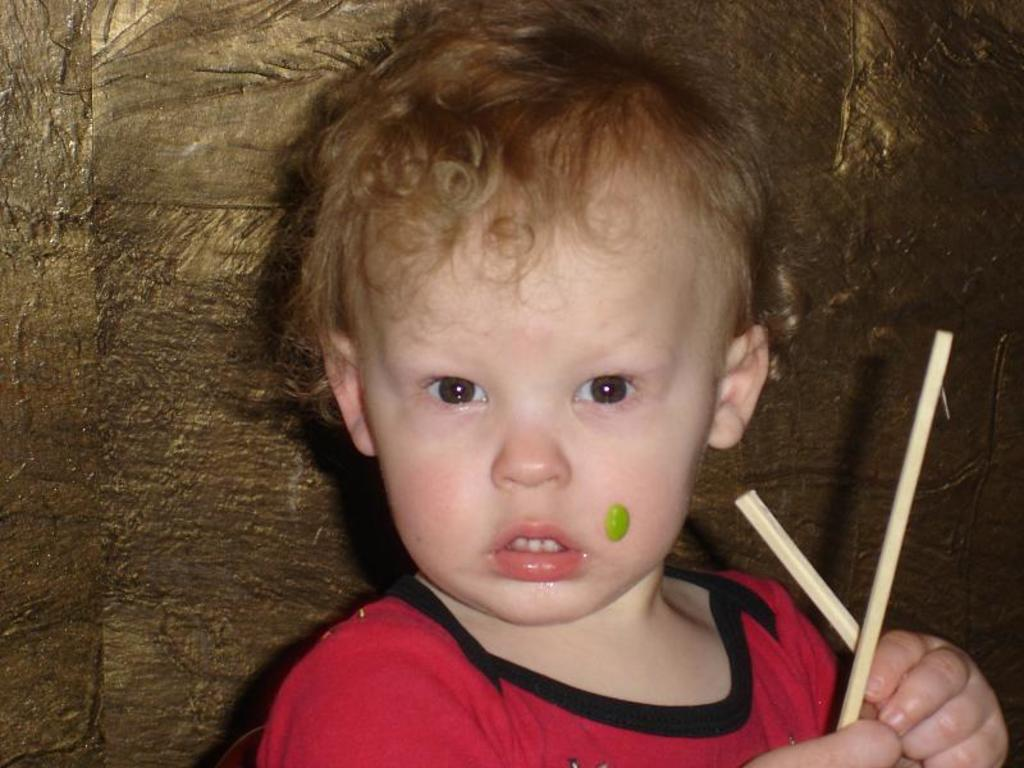What is the main subject of the picture? The main subject of the picture is a kid. What is the kid holding in the picture? The kid is holding sticks in the picture. What is the kid's focus in the picture? The kid is staring at something in the picture. What type of pies is the kid baking in the picture? There is no indication in the image that the kid is baking pies, as the kid is holding sticks and not engaging in any baking activity. 